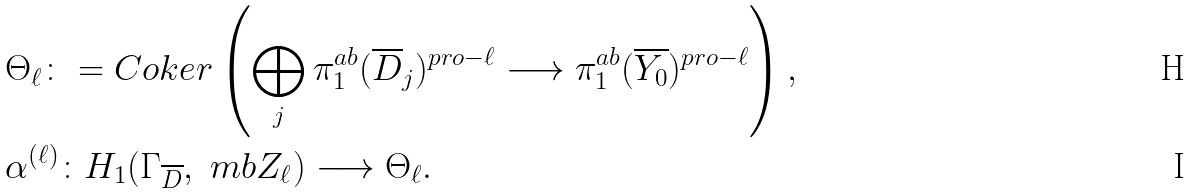Convert formula to latex. <formula><loc_0><loc_0><loc_500><loc_500>& \Theta _ { \ell } \colon = C o k e r \left ( \bigoplus _ { j } \pi _ { 1 } ^ { a b } ( \overline { D } _ { j } ) ^ { p r o - \ell } \longrightarrow \pi _ { 1 } ^ { a b } ( \overline { Y _ { 0 } } ) ^ { p r o - \ell } \right ) , \\ & \alpha ^ { ( \ell ) } \colon H _ { 1 } ( \Gamma _ { \overline { D } } , \ m b { Z } _ { \ell } ) \longrightarrow \Theta _ { \ell } .</formula> 